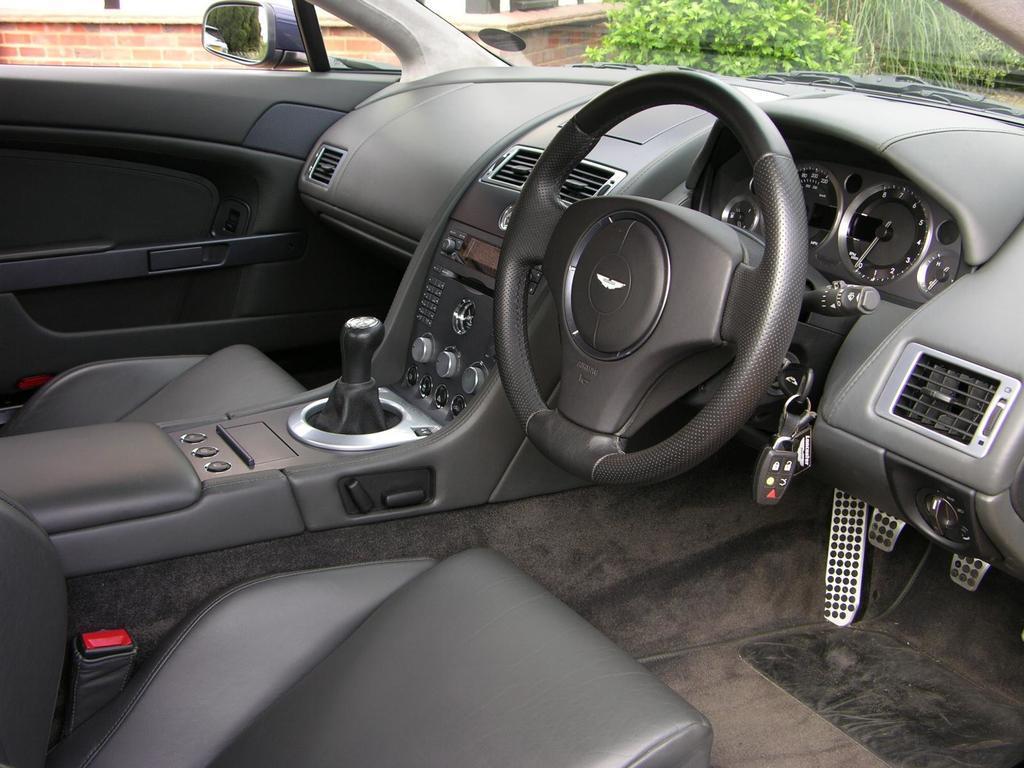How would you summarize this image in a sentence or two? In this image, I can see the inside view of the car. This is a steering wheel. I can see an auto gauge, regulators, clutch, brake, accelerator attached to the car. These are the seats. I can see a side mirror. This is a key. I can see a tree through the car. Here is the car door. This is a dashboard This is a wall. 